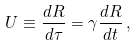Convert formula to latex. <formula><loc_0><loc_0><loc_500><loc_500>U \equiv \frac { d R } { d \tau } = \gamma { \frac { d R } { d t } } \, ,</formula> 